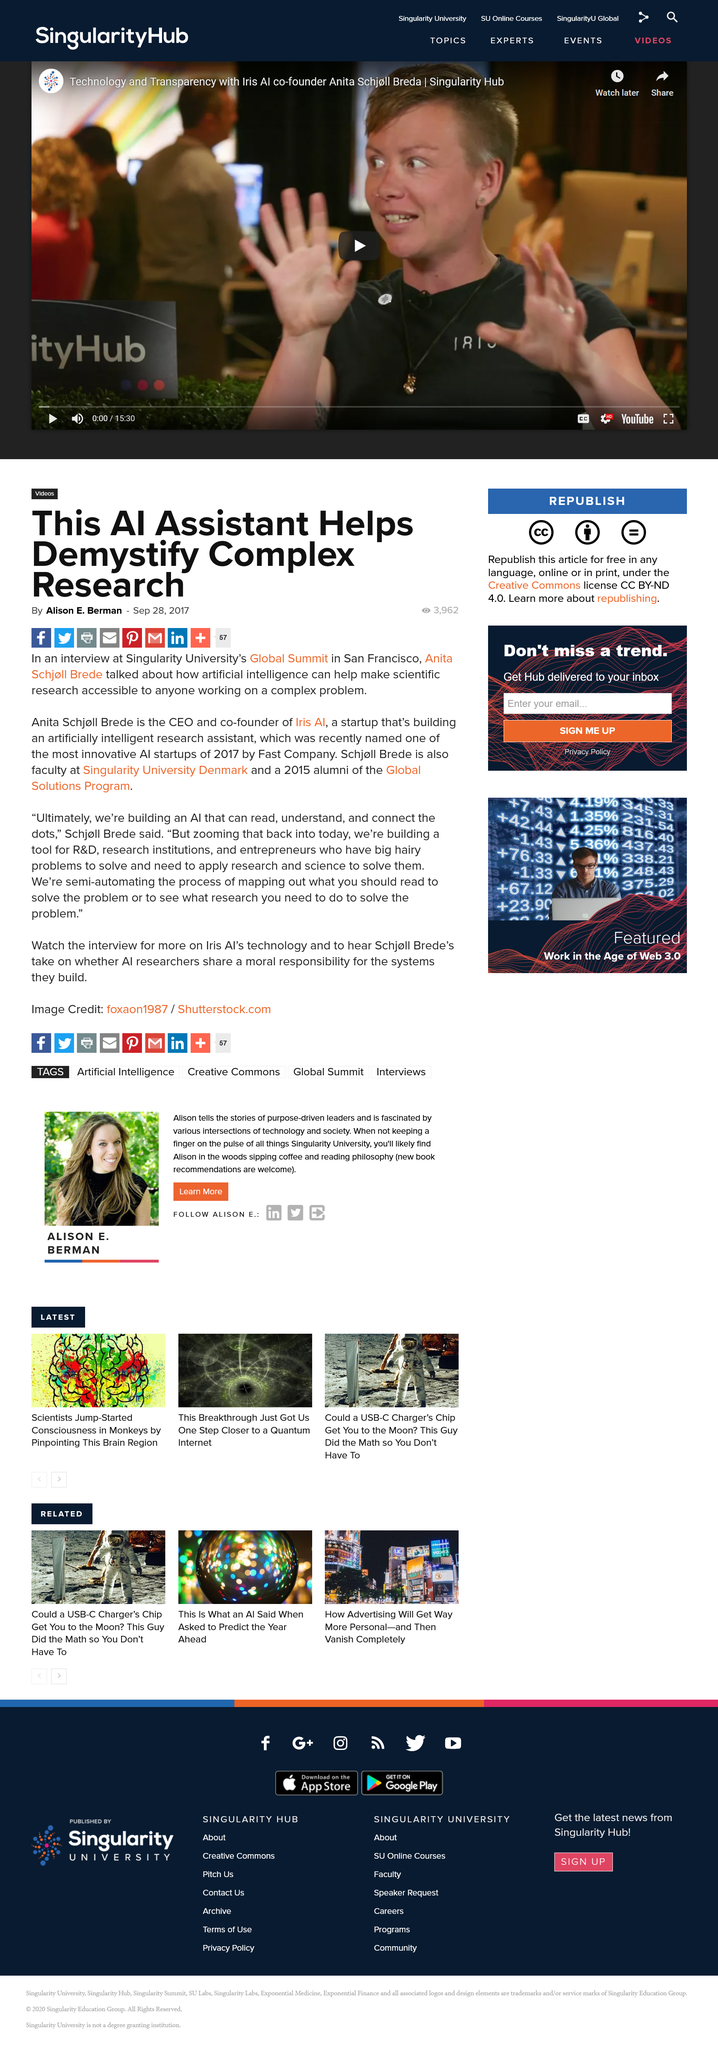Highlight a few significant elements in this photo. Anita Schjoll Brede is the CEO and founder of Iris AI, a startup that is developing an artificially intelligent research assistant. The article is written by Alison E. Berman. Singularity University's Global Summit was held in San Francisco, where it took place. 